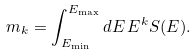Convert formula to latex. <formula><loc_0><loc_0><loc_500><loc_500>m _ { k } = \int _ { E _ { \min } } ^ { E _ { \max } } d E \, E ^ { k } S ( E ) .</formula> 